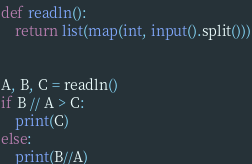Convert code to text. <code><loc_0><loc_0><loc_500><loc_500><_Python_>def readln():
    return list(map(int, input().split()))


A, B, C = readln()
if B // A > C:
    print(C)
else:
    print(B//A)
</code> 